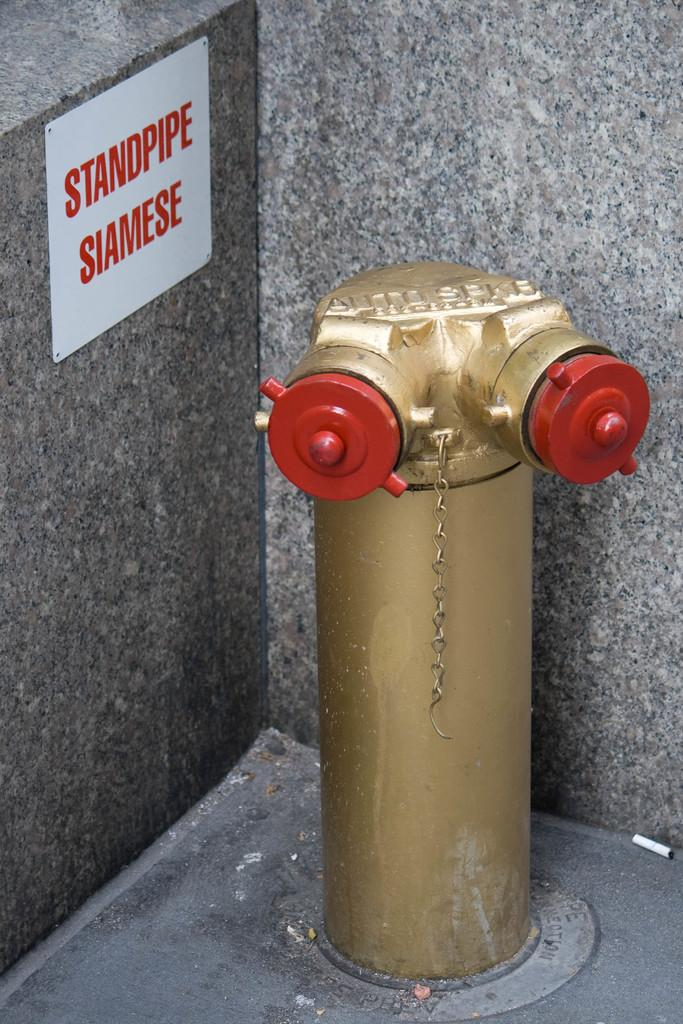What can be seen in the image related to water supply? There is a water pipe in the image. What is attached to the wall in the image? There is a board on the wall in the image. What is written or displayed on the board? There is text on the board. Is there any quicksand visible in the image? No, there is no quicksand present in the image. What type of quiver is hanging on the wall next to the board? There is no quiver present in the image; only the water pipe, board, and text are visible. 